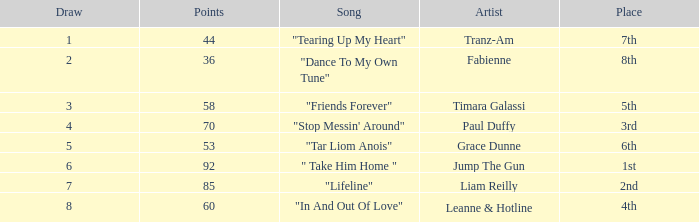What's the song of artist liam reilly? "Lifeline". 